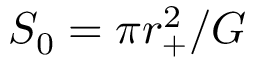Convert formula to latex. <formula><loc_0><loc_0><loc_500><loc_500>S _ { 0 } = \pi r _ { + } ^ { 2 } / G</formula> 